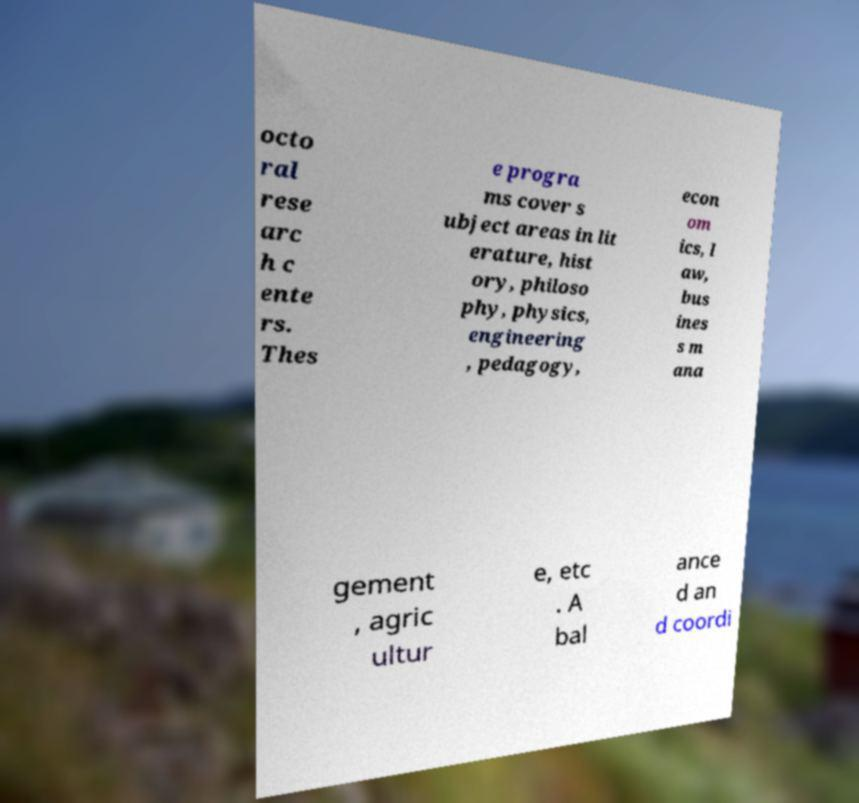Please identify and transcribe the text found in this image. octo ral rese arc h c ente rs. Thes e progra ms cover s ubject areas in lit erature, hist ory, philoso phy, physics, engineering , pedagogy, econ om ics, l aw, bus ines s m ana gement , agric ultur e, etc . A bal ance d an d coordi 